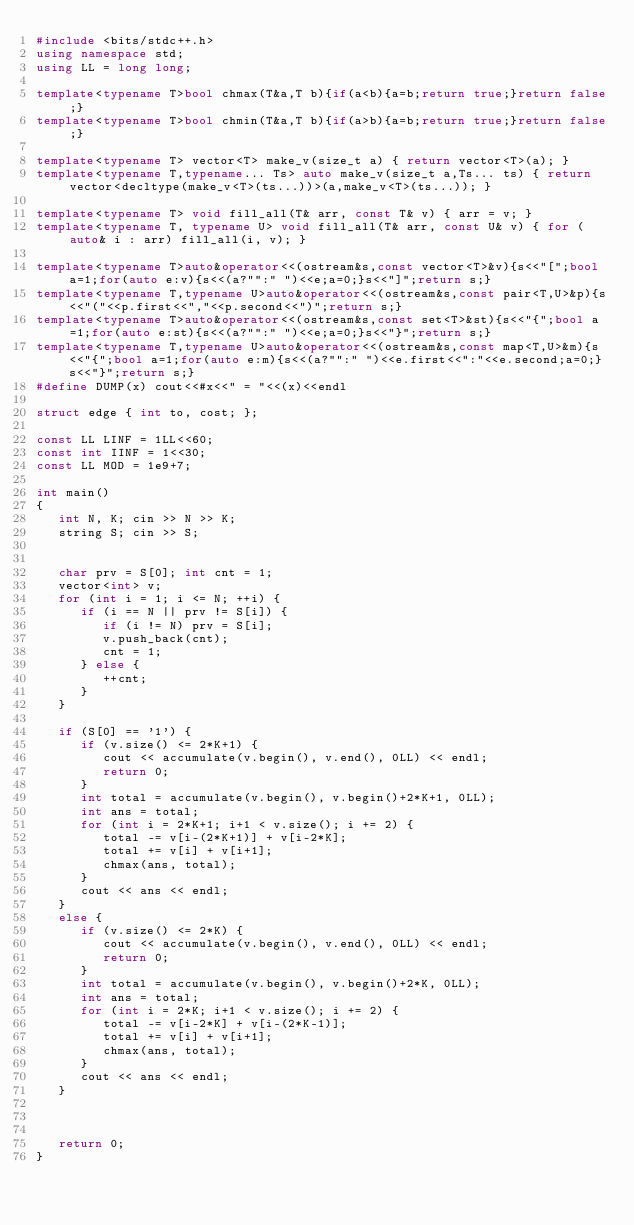Convert code to text. <code><loc_0><loc_0><loc_500><loc_500><_C++_>#include <bits/stdc++.h>
using namespace std;
using LL = long long;

template<typename T>bool chmax(T&a,T b){if(a<b){a=b;return true;}return false;}
template<typename T>bool chmin(T&a,T b){if(a>b){a=b;return true;}return false;}

template<typename T> vector<T> make_v(size_t a) { return vector<T>(a); }
template<typename T,typename... Ts> auto make_v(size_t a,Ts... ts) { return vector<decltype(make_v<T>(ts...))>(a,make_v<T>(ts...)); }

template<typename T> void fill_all(T& arr, const T& v) { arr = v; }
template<typename T, typename U> void fill_all(T& arr, const U& v) { for (auto& i : arr) fill_all(i, v); }

template<typename T>auto&operator<<(ostream&s,const vector<T>&v){s<<"[";bool a=1;for(auto e:v){s<<(a?"":" ")<<e;a=0;}s<<"]";return s;}
template<typename T,typename U>auto&operator<<(ostream&s,const pair<T,U>&p){s<<"("<<p.first<<","<<p.second<<")";return s;}
template<typename T>auto&operator<<(ostream&s,const set<T>&st){s<<"{";bool a=1;for(auto e:st){s<<(a?"":" ")<<e;a=0;}s<<"}";return s;}
template<typename T,typename U>auto&operator<<(ostream&s,const map<T,U>&m){s<<"{";bool a=1;for(auto e:m){s<<(a?"":" ")<<e.first<<":"<<e.second;a=0;}s<<"}";return s;}
#define DUMP(x) cout<<#x<<" = "<<(x)<<endl

struct edge { int to, cost; };

const LL LINF = 1LL<<60;
const int IINF = 1<<30;
const LL MOD = 1e9+7;

int main()
{
   int N, K; cin >> N >> K;
   string S; cin >> S;


   char prv = S[0]; int cnt = 1;
   vector<int> v;
   for (int i = 1; i <= N; ++i) {
      if (i == N || prv != S[i]) {
         if (i != N) prv = S[i];
         v.push_back(cnt);
         cnt = 1;
      } else {
         ++cnt;
      }
   }

   if (S[0] == '1') {
      if (v.size() <= 2*K+1) {
         cout << accumulate(v.begin(), v.end(), 0LL) << endl;
         return 0;
      }
      int total = accumulate(v.begin(), v.begin()+2*K+1, 0LL);
      int ans = total;
      for (int i = 2*K+1; i+1 < v.size(); i += 2) {
         total -= v[i-(2*K+1)] + v[i-2*K];
         total += v[i] + v[i+1];
         chmax(ans, total);
      }
      cout << ans << endl;
   }
   else {
      if (v.size() <= 2*K) {
         cout << accumulate(v.begin(), v.end(), 0LL) << endl;
         return 0;
      }
      int total = accumulate(v.begin(), v.begin()+2*K, 0LL);
      int ans = total;
      for (int i = 2*K; i+1 < v.size(); i += 2) {
         total -= v[i-2*K] + v[i-(2*K-1)];
         total += v[i] + v[i+1];
         chmax(ans, total);
      }
      cout << ans << endl;
   }



   return 0;
}
</code> 